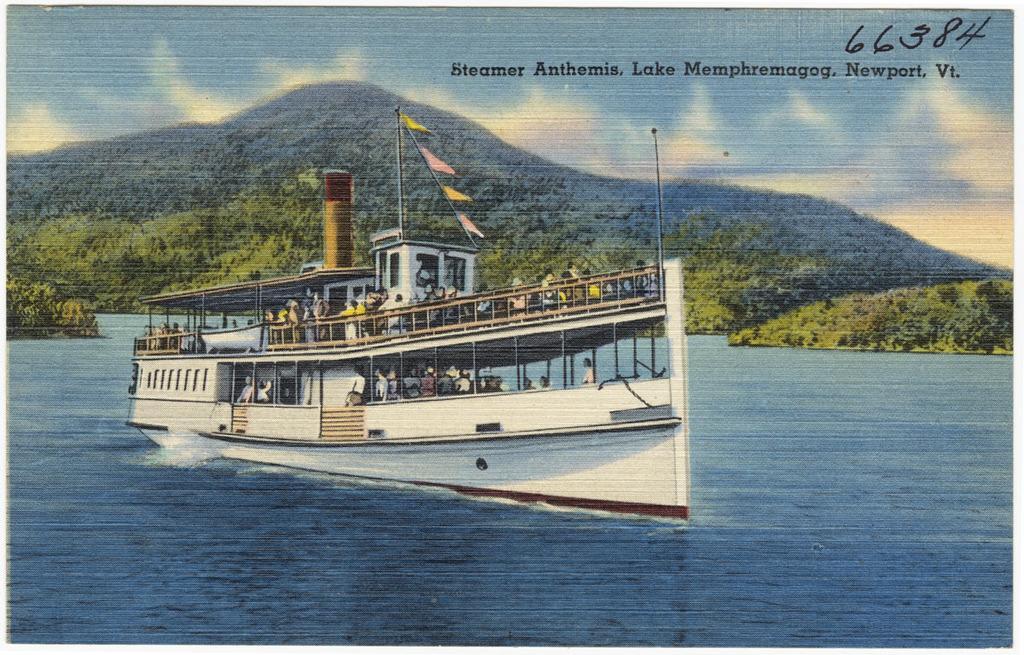Can you describe this image briefly? This picture is consists of a portrait, which includes a big ship on the water and there are trees in the image. 